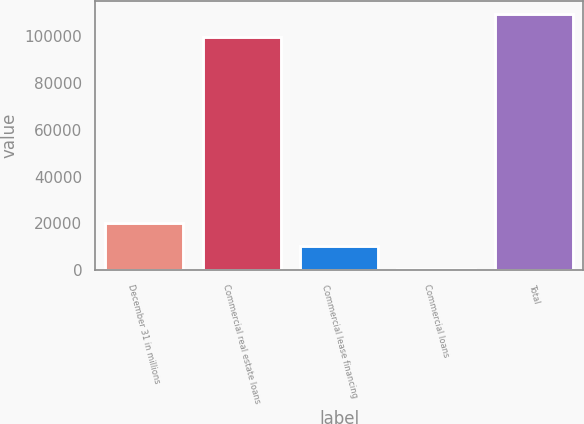<chart> <loc_0><loc_0><loc_500><loc_500><bar_chart><fcel>December 31 in millions<fcel>Commercial real estate loans<fcel>Commercial lease financing<fcel>Commercial loans<fcel>Total<nl><fcel>20331.8<fcel>99608<fcel>10318.9<fcel>306<fcel>109621<nl></chart> 